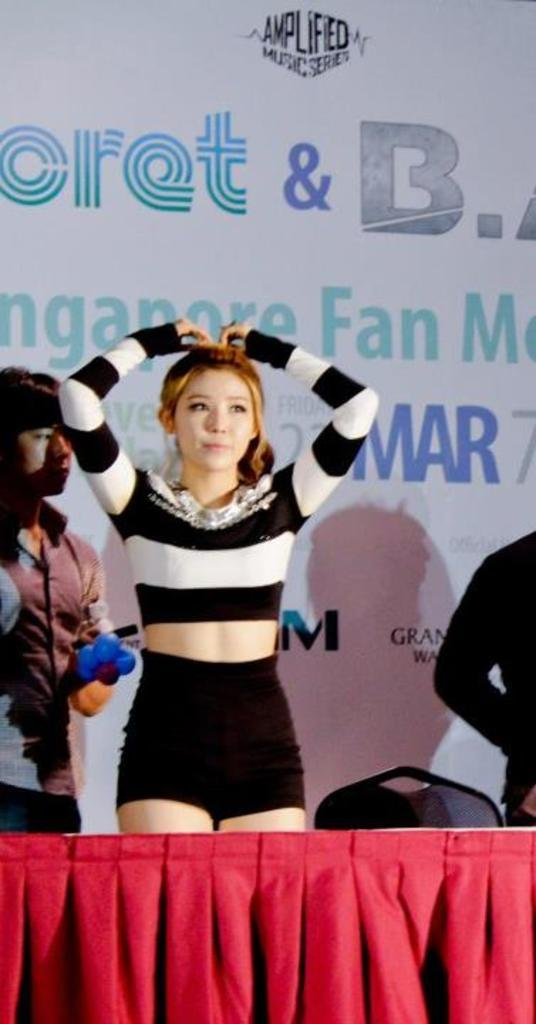<image>
Summarize the visual content of the image. A women resting her hands on her head in front of a sign for a fan meeting 